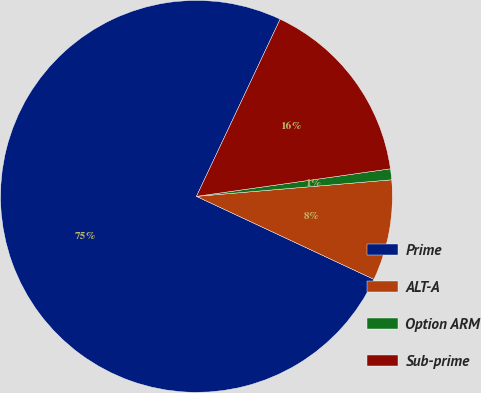<chart> <loc_0><loc_0><loc_500><loc_500><pie_chart><fcel>Prime<fcel>ALT-A<fcel>Option ARM<fcel>Sub-prime<nl><fcel>75.06%<fcel>8.31%<fcel>0.9%<fcel>15.73%<nl></chart> 